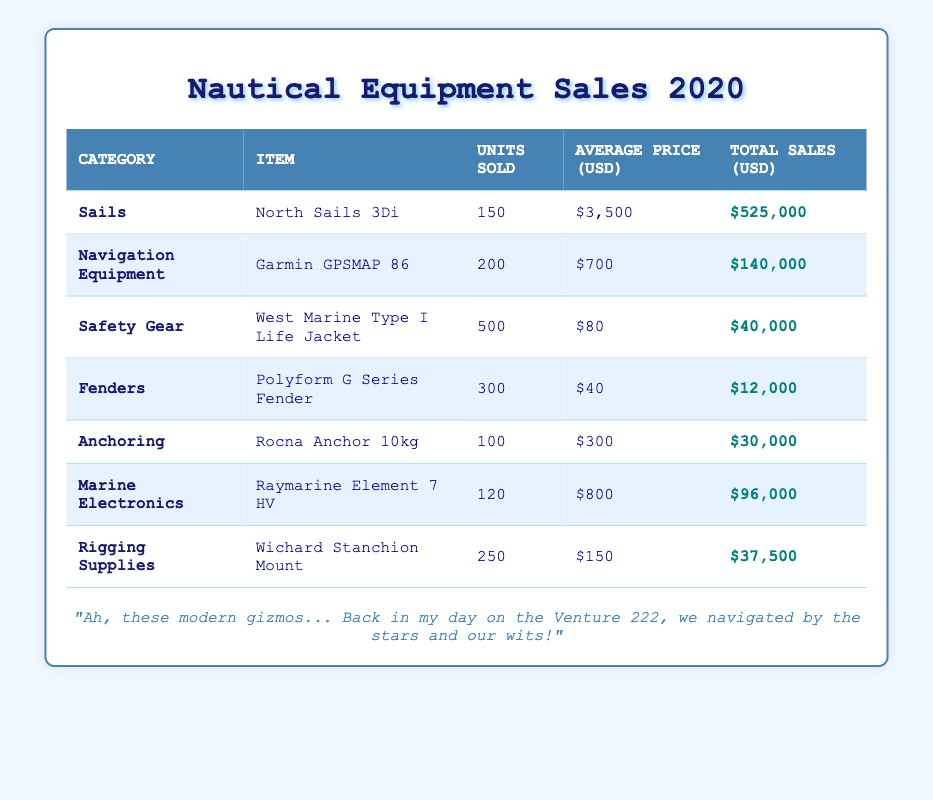What is the total sales amount for North Sails 3Di? The total sales amount for North Sails 3Di can be found directly in the table under the "Total Sales (USD)" column for that item. It shows $525,000.
Answer: $525,000 How many units were sold of the Garmin GPSMAP 86? The number of units sold for the Garmin GPSMAP 86 is listed under the "Units Sold" column corresponding to that item, which is 200 units.
Answer: 200 What is the combined total sales for safety gear and fenders? To find the combined total sales for safety gear and fenders, I add the total sales for the West Marine Type I Life Jacket ($40,000) and the Polyform G Series Fender ($12,000). Thus, the combined total is $40,000 + $12,000 = $52,000.
Answer: $52,000 Is the average price of the Rocna Anchor 10kg higher than $250? The average price of the Rocna Anchor 10kg is listed in the table as $300, which is indeed higher than $250.
Answer: Yes What category had the highest total sales and what was the amount? Reviewing the total sales amounts for each category in the table, the category with the highest total sales is "Sails," with total sales of $525,000.
Answer: Sails, $525,000 What is the average selling price of the life jackets sold? The average price of the West Marine Type I Life Jacket can be found in the "Average Price (USD)" column and is $80. Since only one product is listed under safety gear, the average is the same as that price.
Answer: $80 How many more units of Wichard Stanchion Mount were sold than the Rocna Anchor 10kg? To find out how many more Wichard Stanchion Mounts were sold than Rocna Anchors, I subtract the number of units sold for the Rocna Anchor (100 units) from those sold for the Wichard Stanchion Mount (250 units). Thus, 250 - 100 = 150 more units were sold of the Wichard Stanchion Mount.
Answer: 150 Which category had fewer than 100 units sold? I review the "Units Sold" column and see that the "Anchoring" category had 100 units sold, while "Fenders" had 300, "Safety Gear" had 500, and the rest were higher than 100 as well. Therefore, none of the categories listed have fewer than 100 units sold.
Answer: None What is the total sales amount across all categories? To find the total sales across all categories, I sum the total sales of each item: $525,000 + $140,000 + $40,000 + $12,000 + $30,000 + $96,000 + $37,500, which equals $880,500.
Answer: $880,500 